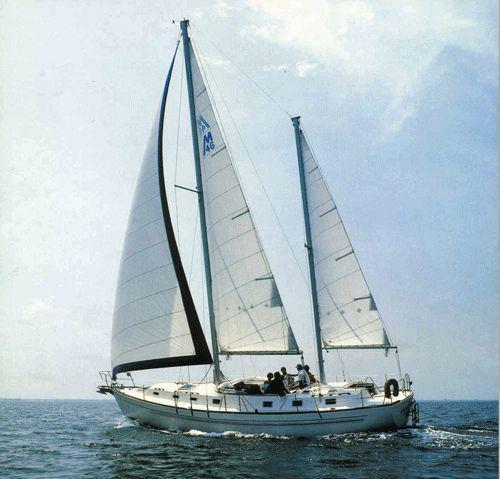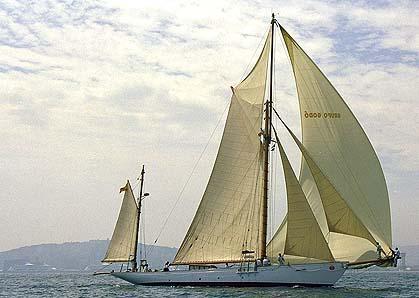The first image is the image on the left, the second image is the image on the right. Analyze the images presented: Is the assertion "One image shows a boat with exactly three sails." valid? Answer yes or no. Yes. 